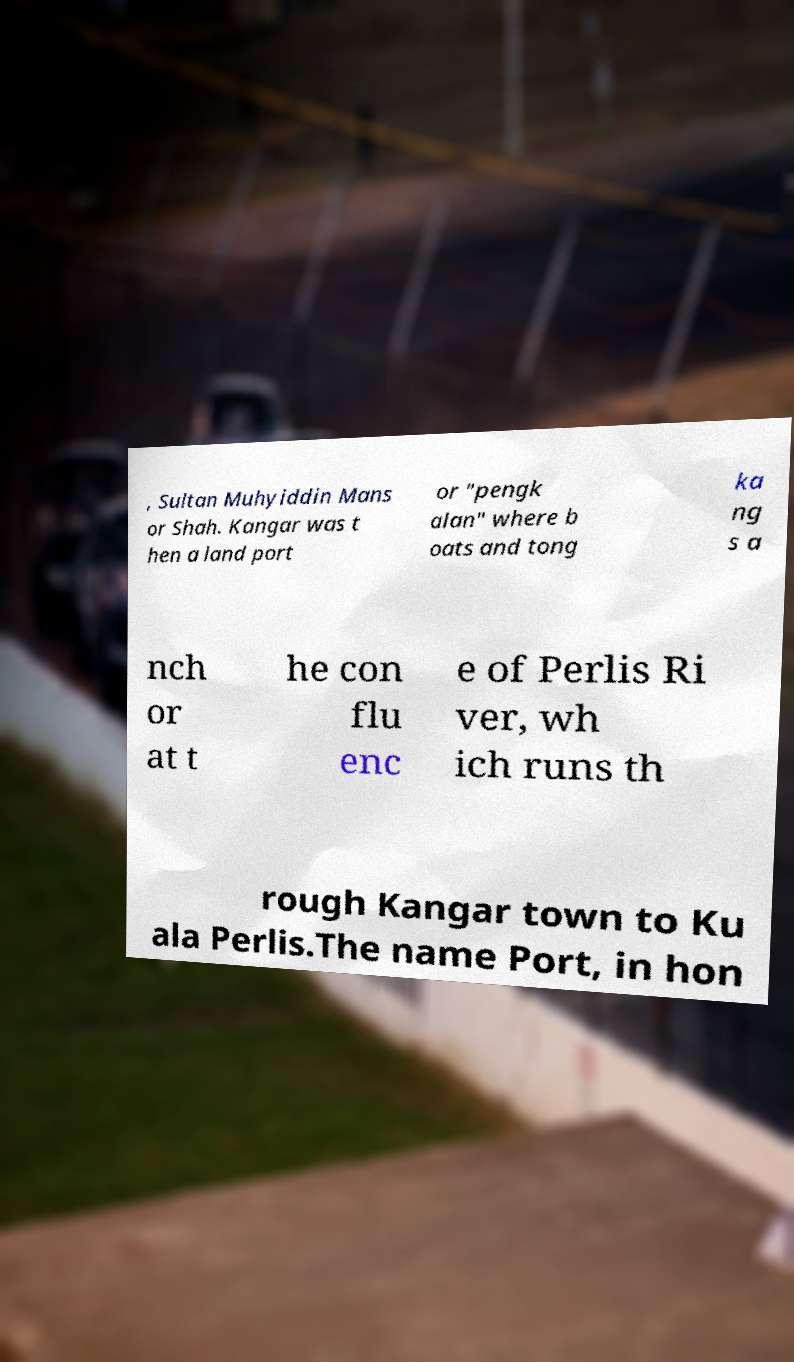I need the written content from this picture converted into text. Can you do that? , Sultan Muhyiddin Mans or Shah. Kangar was t hen a land port or "pengk alan" where b oats and tong ka ng s a nch or at t he con flu enc e of Perlis Ri ver, wh ich runs th rough Kangar town to Ku ala Perlis.The name Port, in hon 